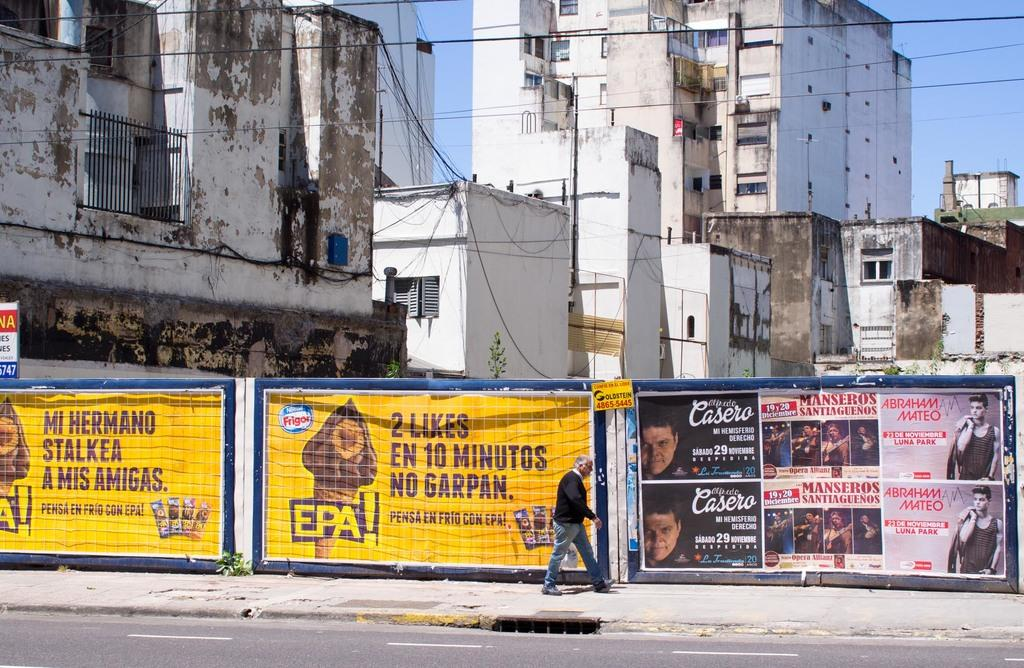<image>
Render a clear and concise summary of the photo. may adsa re hangin on the fence including one for Abraham Mateo 